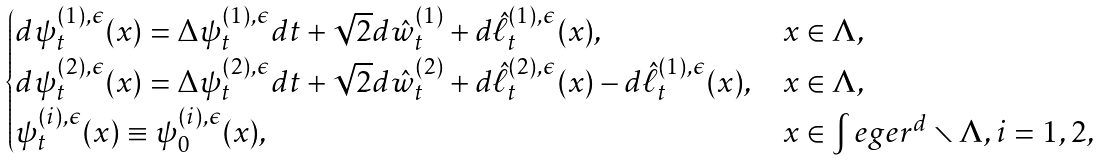<formula> <loc_0><loc_0><loc_500><loc_500>\begin{cases} d \psi _ { t } ^ { ( 1 ) , \epsilon } ( x ) = \Delta \psi _ { t } ^ { ( 1 ) , \epsilon } d t + \sqrt { 2 } d \hat { w } _ { t } ^ { ( 1 ) } + d \hat { \ell } _ { t } ^ { ( 1 ) , \epsilon } ( x ) , & x \in \Lambda , \\ d \psi _ { t } ^ { ( 2 ) , \epsilon } ( x ) = \Delta \psi _ { t } ^ { ( 2 ) , \epsilon } d t + \sqrt { 2 } d \hat { w } _ { t } ^ { ( 2 ) } + d \hat { \ell } _ { t } ^ { ( 2 ) , \epsilon } ( x ) - d \hat { \ell } _ { t } ^ { ( 1 ) , \epsilon } ( x ) , & x \in \Lambda , \\ \psi _ { t } ^ { ( i ) , \epsilon } ( x ) \equiv \psi _ { 0 } ^ { ( i ) , \epsilon } ( x ) , & x \in \int e g e r ^ { d } \smallsetminus \Lambda , i = 1 , 2 , \\ \end{cases}</formula> 